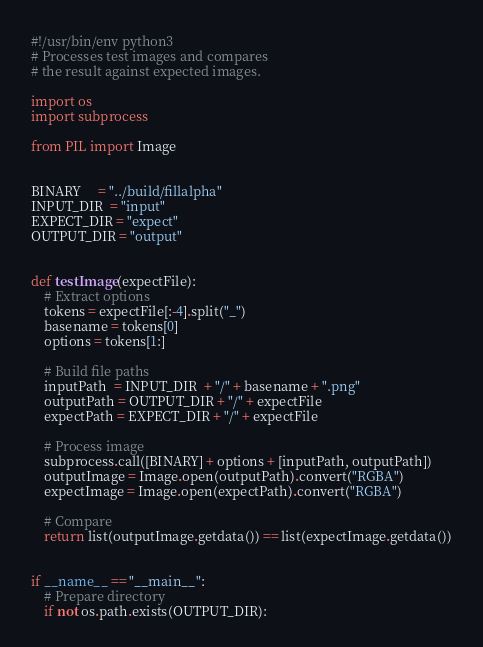<code> <loc_0><loc_0><loc_500><loc_500><_Python_>#!/usr/bin/env python3
# Processes test images and compares
# the result against expected images.

import os
import subprocess

from PIL import Image


BINARY     = "../build/fillalpha"
INPUT_DIR  = "input"
EXPECT_DIR = "expect"
OUTPUT_DIR = "output"


def testImage(expectFile):
	# Extract options
	tokens = expectFile[:-4].split("_")
	basename = tokens[0]
	options = tokens[1:]

	# Build file paths
	inputPath  = INPUT_DIR  + "/" + basename + ".png"
	outputPath = OUTPUT_DIR + "/" + expectFile
	expectPath = EXPECT_DIR + "/" + expectFile

	# Process image
	subprocess.call([BINARY] + options + [inputPath, outputPath])
	outputImage = Image.open(outputPath).convert("RGBA")
	expectImage = Image.open(expectPath).convert("RGBA")

	# Compare
	return list(outputImage.getdata()) == list(expectImage.getdata())


if __name__ == "__main__":
	# Prepare directory
	if not os.path.exists(OUTPUT_DIR):</code> 